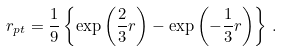Convert formula to latex. <formula><loc_0><loc_0><loc_500><loc_500>r _ { p t } = \frac { 1 } { 9 } \left \{ \exp \left ( \frac { 2 } { 3 } r \right ) - \exp \left ( - \frac { 1 } { 3 } r \right ) \right \} \, .</formula> 